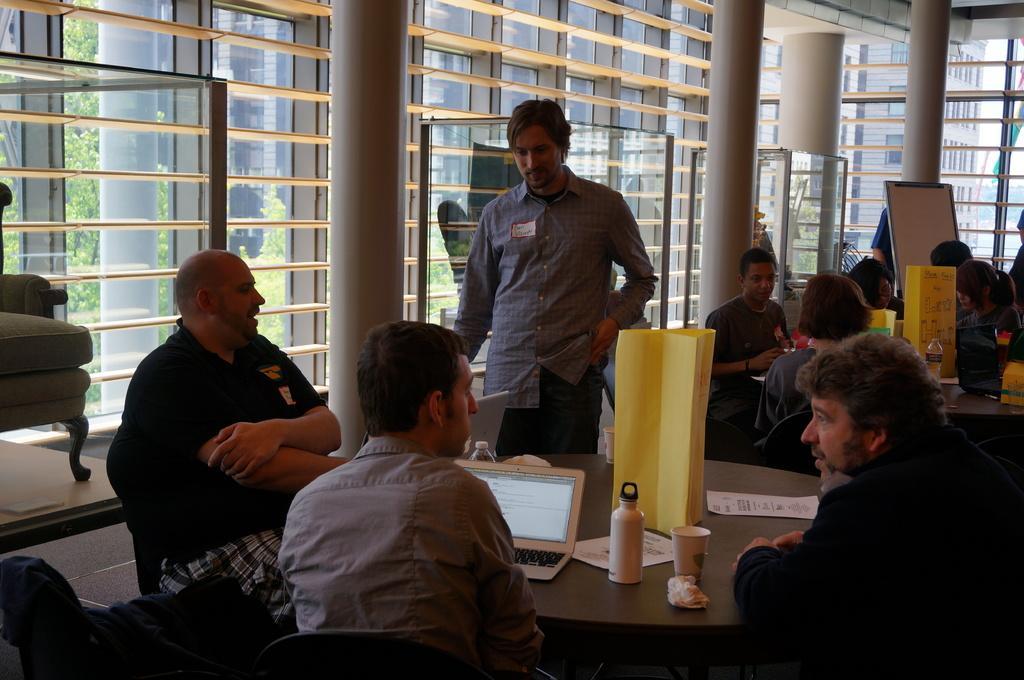Describe this image in one or two sentences. Most of the persons are sitting on chair and this person is standing. On this table there are laptops, bottles, cup, papers and chart. These are poles. Far there is a whiteboard. We can able to see building with windows from this window. We can able to see tree from this window. 